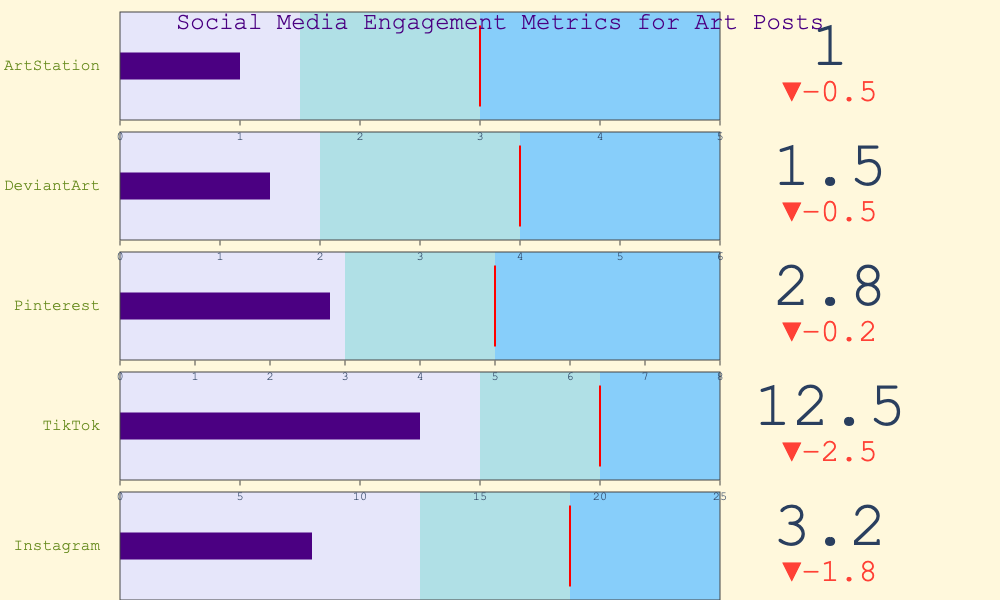what is the title of the chart? The chart's title is written at the top center. The title reads "Social Media Engagement Metrics for Art Posts".
Answer: Social Media Engagement Metrics for Art Posts Which platform has the highest average engagement? Compare the values under the "Average Engagement" data for all platforms. TikTok has the highest value, which is 15.0.
Answer: TikTok How does the performance on Instagram compare to the good benchmark for the same platform? Look at the "Your Performance" and "Good Benchmark" values for Instagram. Your performance is 3.2 and the good benchmark is 7.5, indicating your performance is below the good benchmark.
Answer: Below Which platform has the smallest excellent benchmark and what is it? Compare the "Excellent Benchmark" values across all platforms. ArtStation has the smallest excellent benchmark, with a value of 5.0.
Answer: ArtStation, 5.0 By how much does Your Performance on TikTok differ from the average engagement on the same platform? Subtract "Your Performance" for TikTok (12.5) from the "Average Engagement" for TikTok (15.0). The difference is 15.0 - 12.5 = 2.5.
Answer: 2.5 Which platform has the highest good benchmark value? Compare the "Good Benchmark" values for all platforms. TikTok has the highest good benchmark value of 20.0.
Answer: TikTok How many platforms are displayed in the chart? Count the number of different platform names listed. There are five platforms: Instagram, TikTok, Pinterest, DeviantArt, and ArtStation.
Answer: 5 Is your performance on Pinterest above or below the average engagement for Pinterest? Compare "Your Performance" (2.8) with "Average Engagement" (3.0) for Pinterest. Your performance is below the average engagement.
Answer: Below What color represents the area between the average engagement and the good benchmark? Look at the color used in the range indicating the area between the average engagement and the good benchmark. This color is light blue.
Answer: light blue For DeviantArt, between what ranges is the good benchmark set? Look at the "Good Benchmark" and the values representing ranges. The good benchmark for DeviantArt is set between 4 and 6.
Answer: 4 to 6 